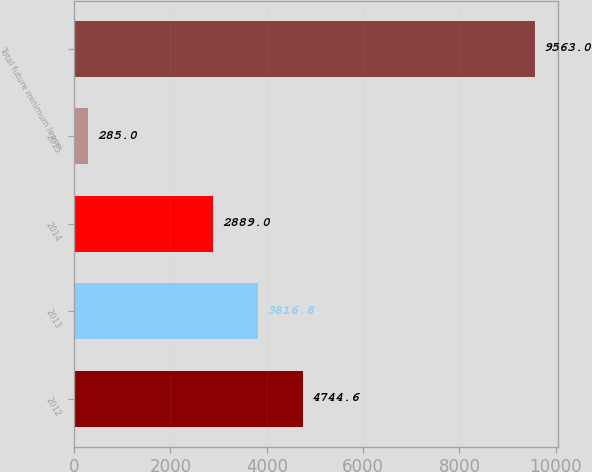Convert chart. <chart><loc_0><loc_0><loc_500><loc_500><bar_chart><fcel>2012<fcel>2013<fcel>2014<fcel>2015<fcel>Total future minimum lease<nl><fcel>4744.6<fcel>3816.8<fcel>2889<fcel>285<fcel>9563<nl></chart> 